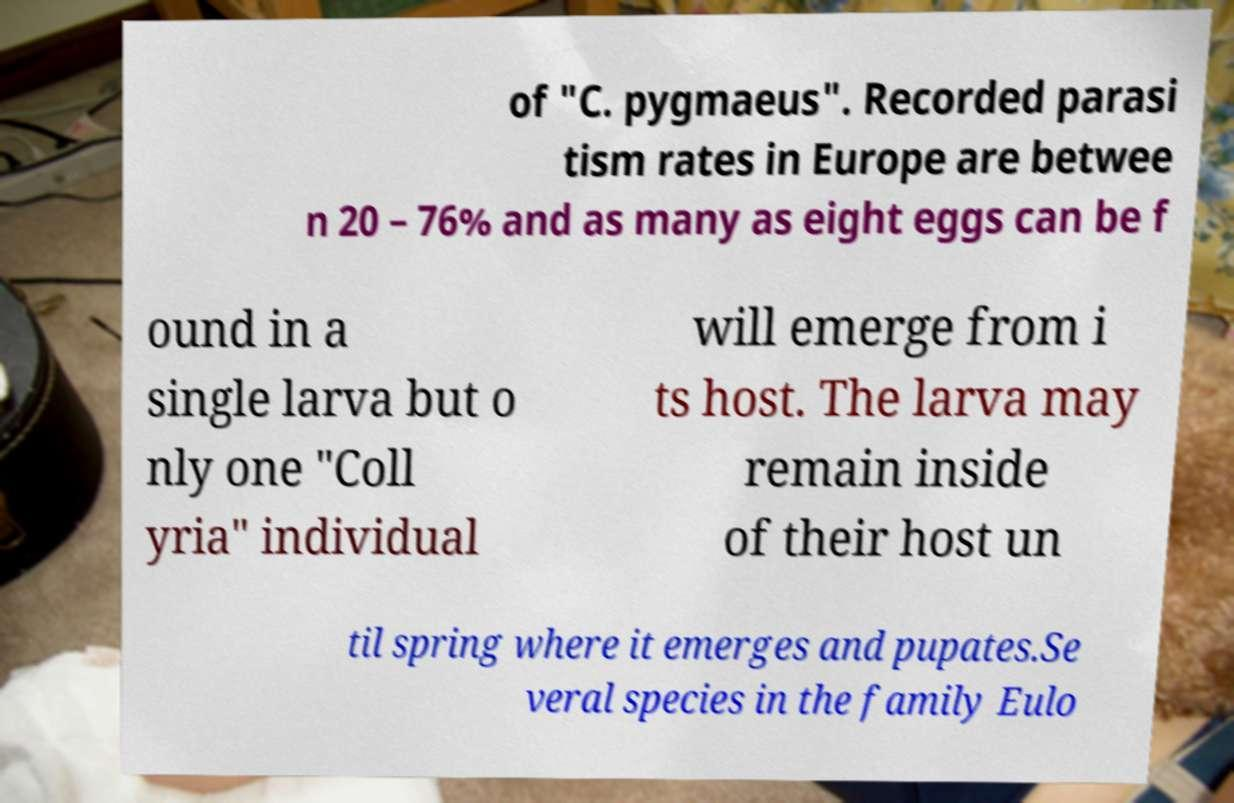There's text embedded in this image that I need extracted. Can you transcribe it verbatim? of "C. pygmaeus". Recorded parasi tism rates in Europe are betwee n 20 – 76% and as many as eight eggs can be f ound in a single larva but o nly one "Coll yria" individual will emerge from i ts host. The larva may remain inside of their host un til spring where it emerges and pupates.Se veral species in the family Eulo 